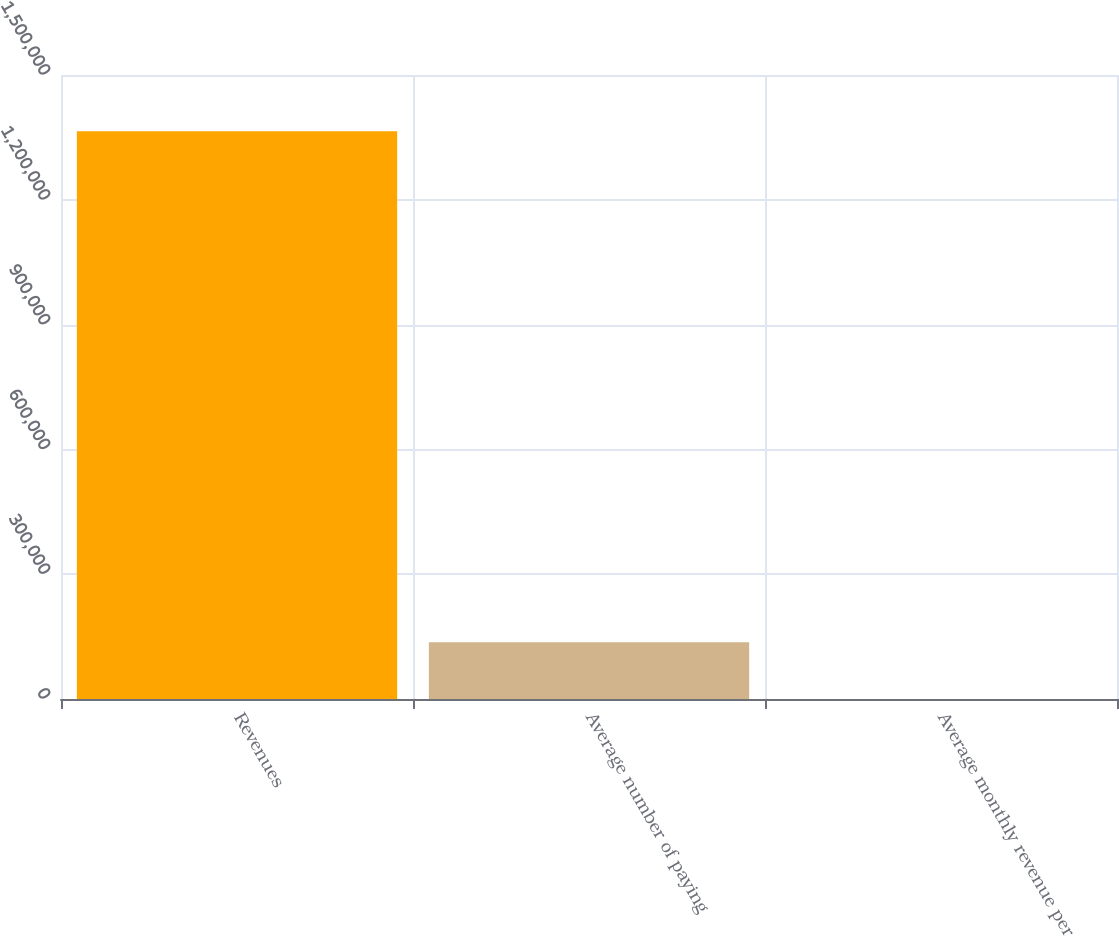Convert chart to OTSL. <chart><loc_0><loc_0><loc_500><loc_500><bar_chart><fcel>Revenues<fcel>Average number of paying<fcel>Average monthly revenue per<nl><fcel>1.36466e+06<fcel>136478<fcel>13.75<nl></chart> 